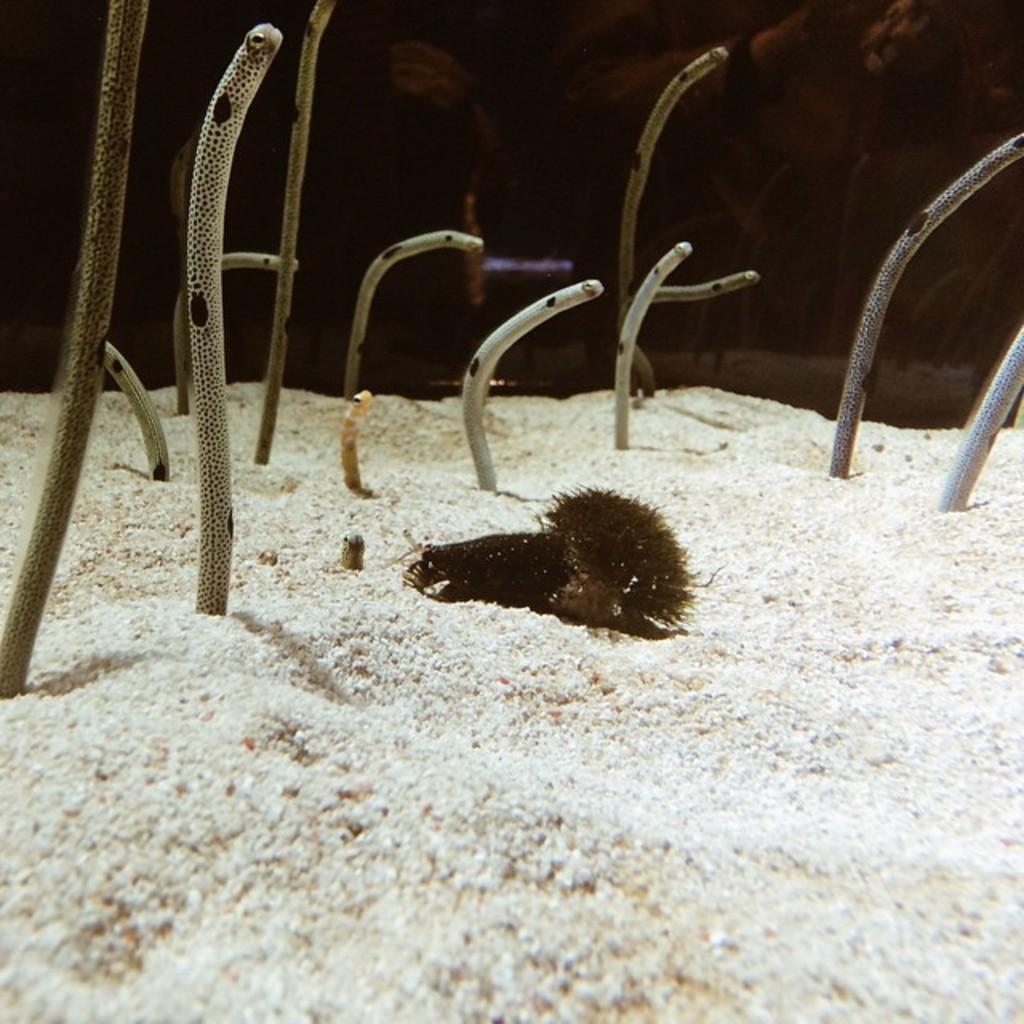How would you summarize this image in a sentence or two? In this image there is an aquatic animal on the sand having few plants. Behind the aquarium there are few persons. 